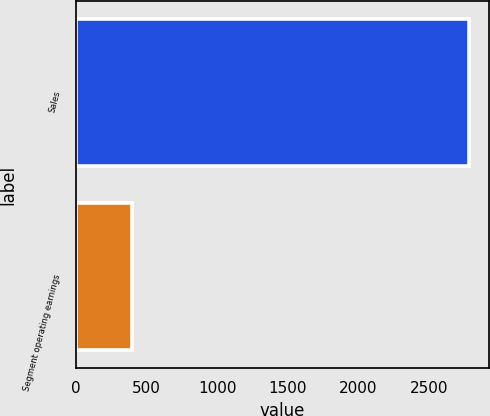Convert chart to OTSL. <chart><loc_0><loc_0><loc_500><loc_500><bar_chart><fcel>Sales<fcel>Segment operating earnings<nl><fcel>2782.6<fcel>397<nl></chart> 